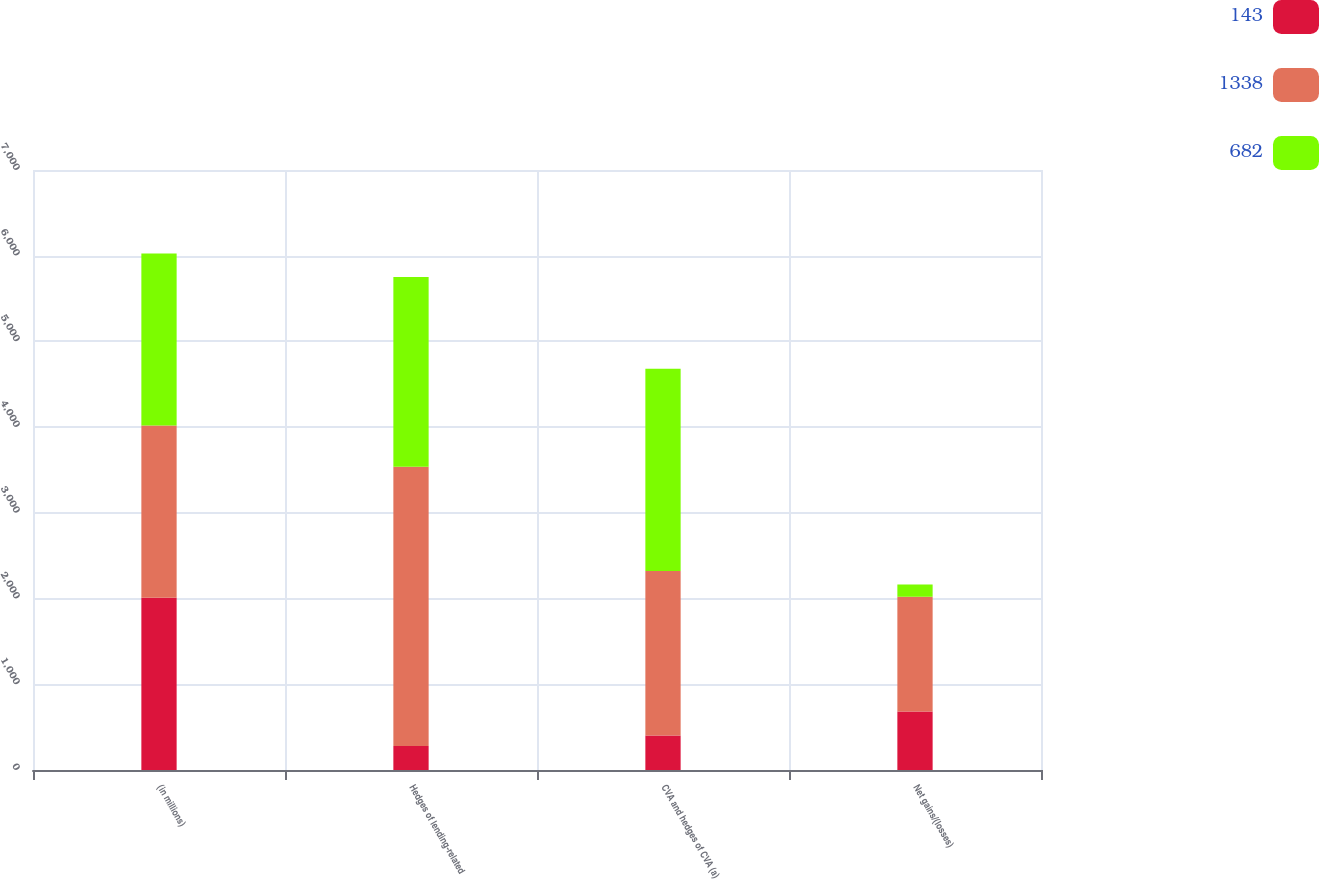Convert chart. <chart><loc_0><loc_0><loc_500><loc_500><stacked_bar_chart><ecel><fcel>(in millions)<fcel>Hedges of lending-related<fcel>CVA and hedges of CVA (a)<fcel>Net gains/(losses)<nl><fcel>143<fcel>2010<fcel>279<fcel>403<fcel>682<nl><fcel>1338<fcel>2009<fcel>3258<fcel>1920<fcel>1338<nl><fcel>682<fcel>2008<fcel>2216<fcel>2359<fcel>143<nl></chart> 